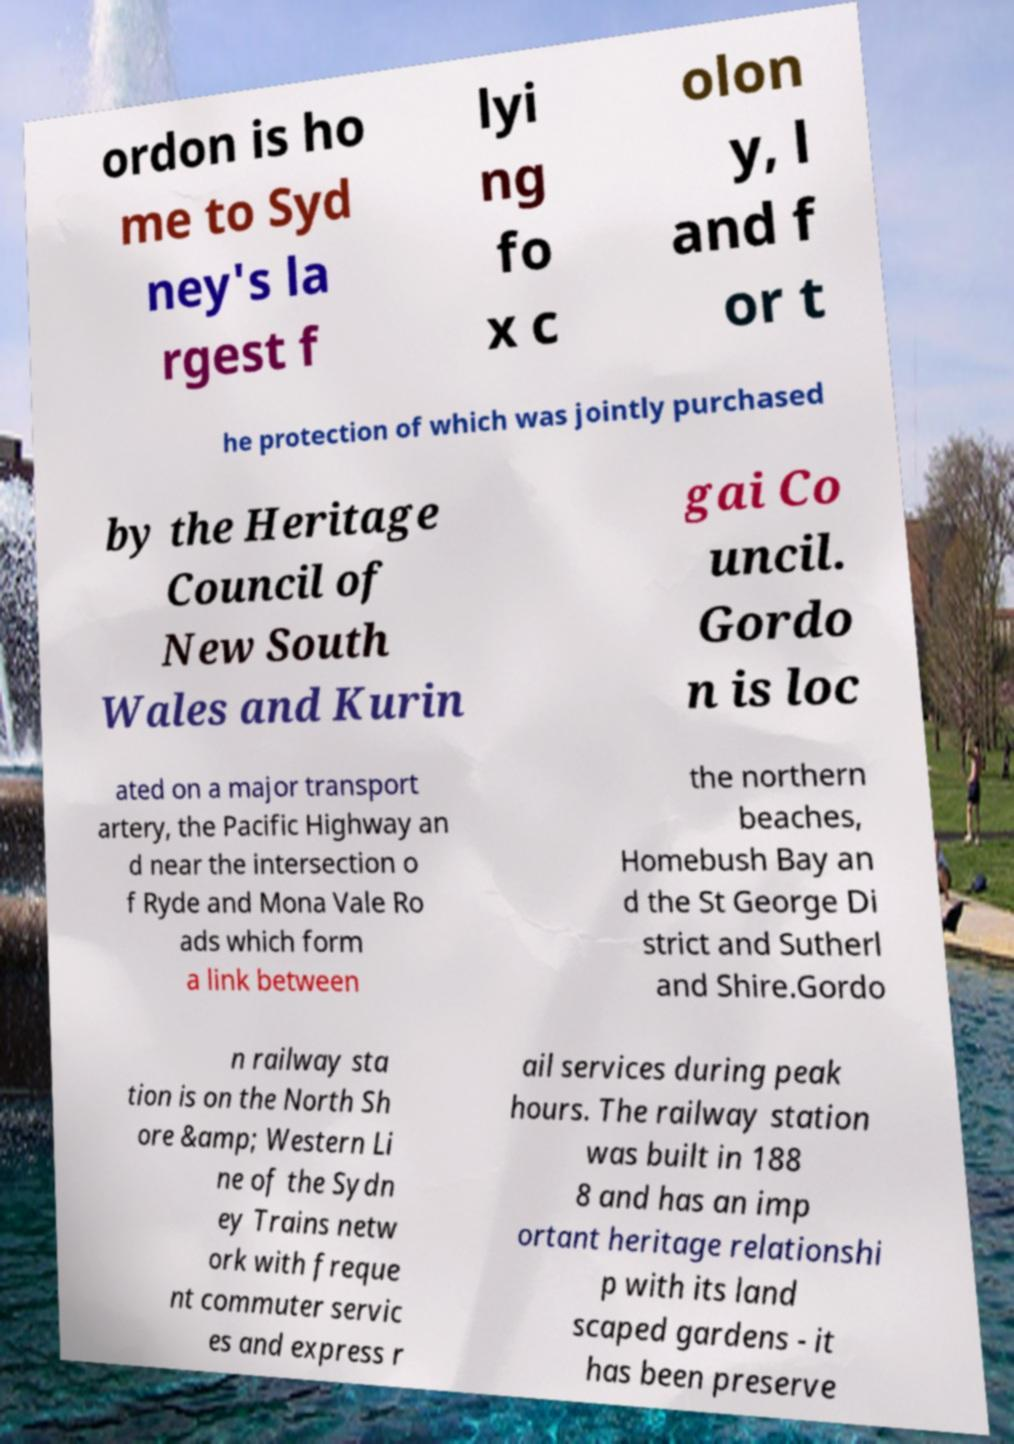There's text embedded in this image that I need extracted. Can you transcribe it verbatim? ordon is ho me to Syd ney's la rgest f lyi ng fo x c olon y, l and f or t he protection of which was jointly purchased by the Heritage Council of New South Wales and Kurin gai Co uncil. Gordo n is loc ated on a major transport artery, the Pacific Highway an d near the intersection o f Ryde and Mona Vale Ro ads which form a link between the northern beaches, Homebush Bay an d the St George Di strict and Sutherl and Shire.Gordo n railway sta tion is on the North Sh ore &amp; Western Li ne of the Sydn ey Trains netw ork with freque nt commuter servic es and express r ail services during peak hours. The railway station was built in 188 8 and has an imp ortant heritage relationshi p with its land scaped gardens - it has been preserve 